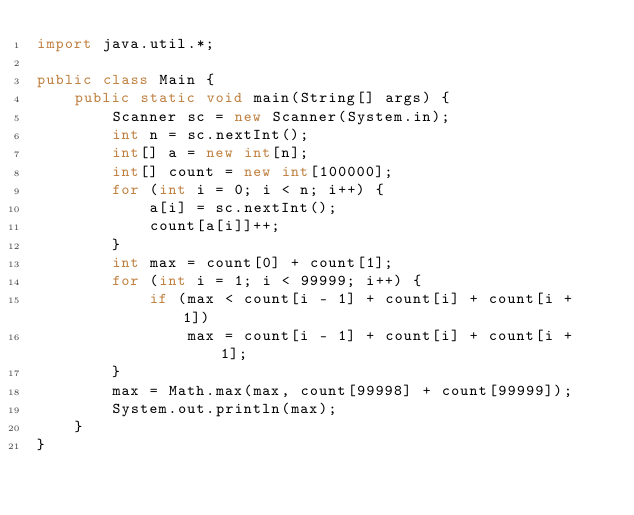Convert code to text. <code><loc_0><loc_0><loc_500><loc_500><_Java_>import java.util.*;

public class Main {
    public static void main(String[] args) {
        Scanner sc = new Scanner(System.in);
        int n = sc.nextInt();
        int[] a = new int[n];
        int[] count = new int[100000];
        for (int i = 0; i < n; i++) {
            a[i] = sc.nextInt();
            count[a[i]]++;
        }
        int max = count[0] + count[1];
        for (int i = 1; i < 99999; i++) {
            if (max < count[i - 1] + count[i] + count[i + 1])
                max = count[i - 1] + count[i] + count[i + 1];
        }
        max = Math.max(max, count[99998] + count[99999]);
        System.out.println(max);
    }
}
</code> 